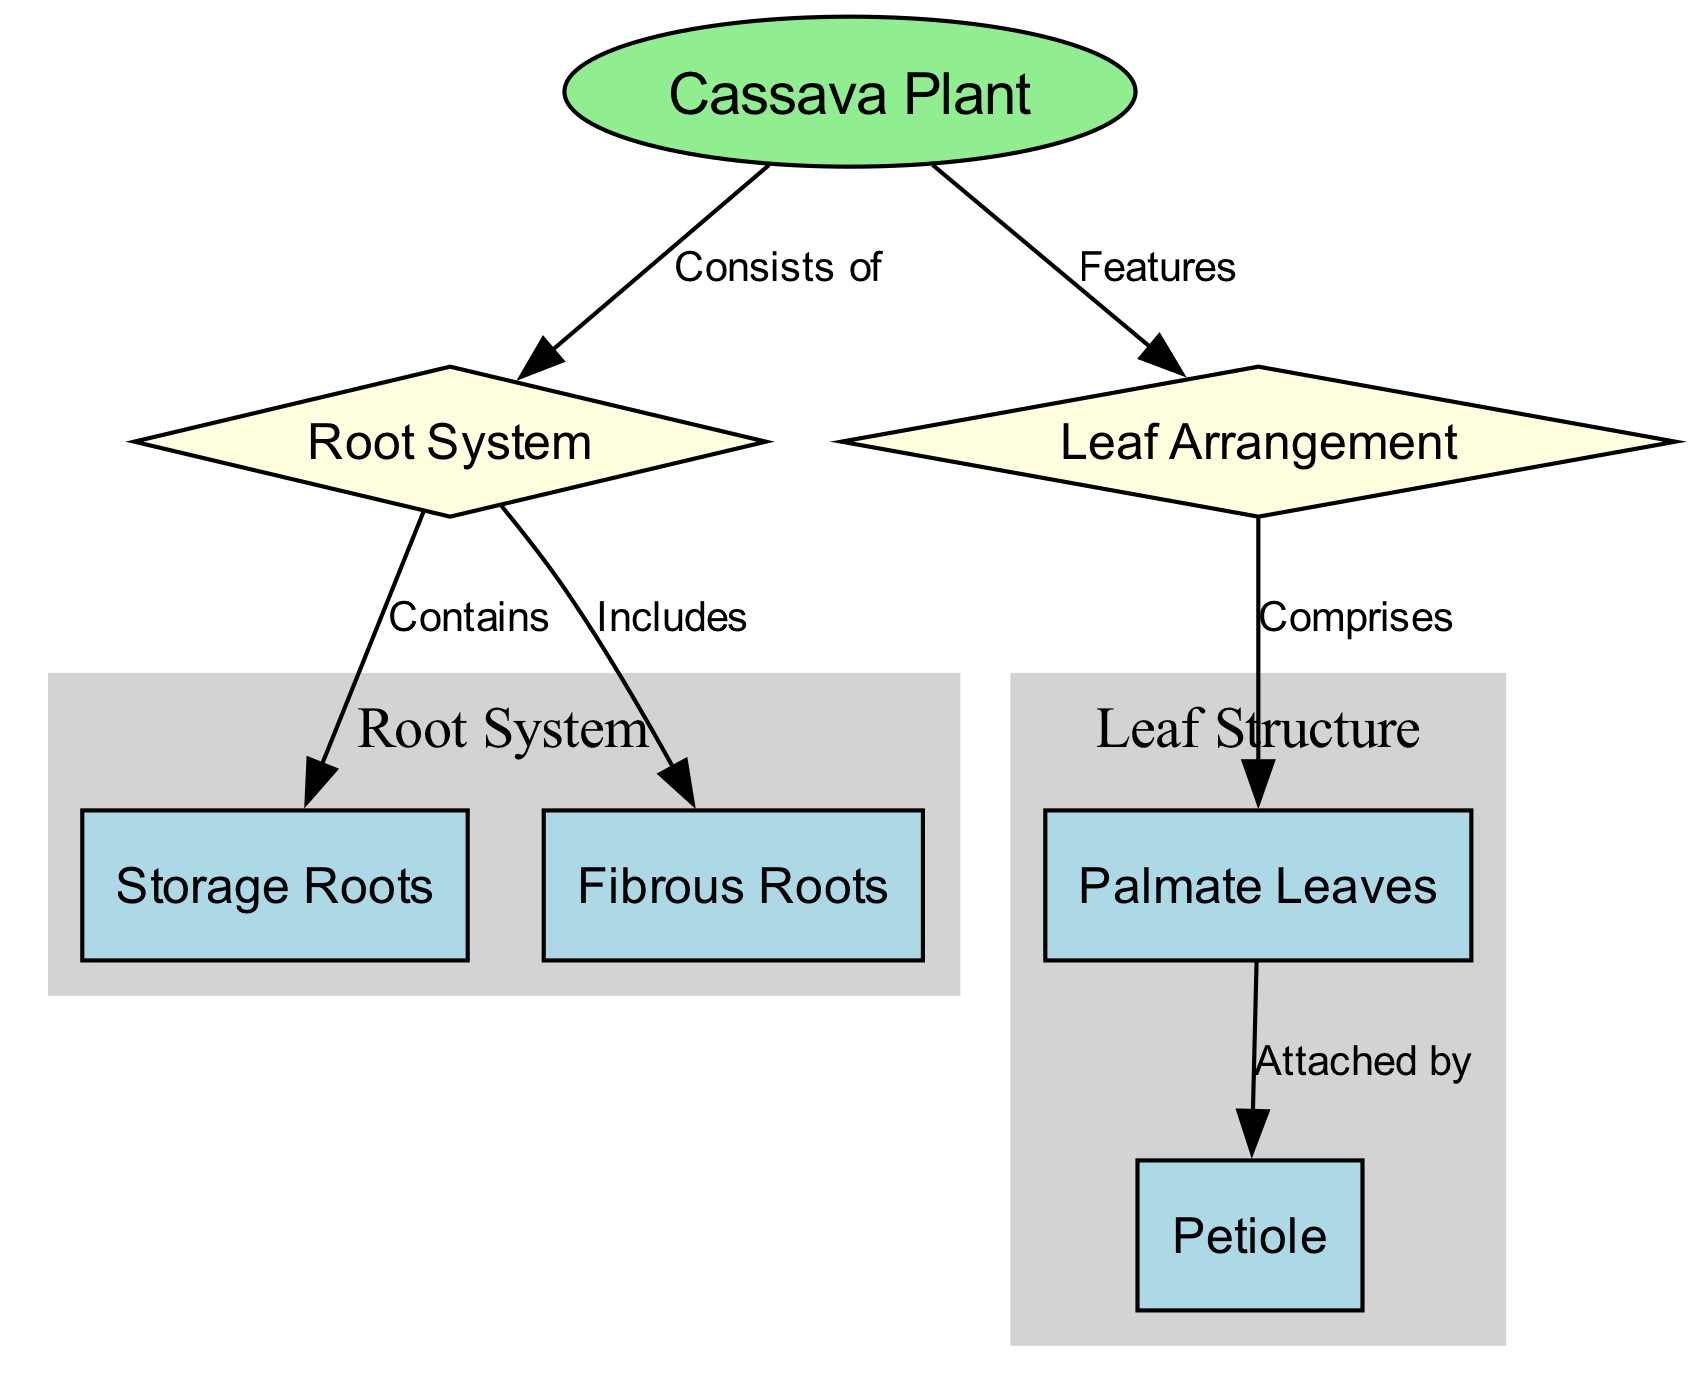What are the two main components of the cassava plant's structure represented in the diagram? The diagram highlights two main components: the root system and the leaf arrangement. These are the primary divisions of the cassava plant as indicated by the edges leading from the cassava plant node to these two nodes.
Answer: Root system and leaf arrangement How many storage roots are connected to the root system in the diagram? The diagram specifies that storage roots are a component of the root system, indicating a singular connection without indicating multiple distinct storage roots. Thus, we consider this as one primary category.
Answer: 1 What type of leaves does the leaf arrangement comprise? The leaf arrangement node indicates that it comprises palmate leaves, as directly connected by the edge labeled "Comprises." This is a direct relationship stated in the diagram.
Answer: Palmate leaves What connects the palmate leaves to the petiole? The diagram shows the connection between palmate leaves and the petiole, represented by the directed edge labeled “Attached by.” This indicates a specific linking relationship.
Answer: Attached by Which component includes fibrous roots? The root system node indicates that it includes fibrous roots specifically as part of its structure through the edge labeled “Includes.” This conveys the hierarchical relationship within the root system.
Answer: Fibrous roots What shape is used to represent the cassava plant in the diagram? The diagram uses an ellipse shape specifically for the cassava plant node, which is an emphasized graphical choice to denote its importance relative to other nodes.
Answer: Ellipse How is the structure of the root system visually represented in this diagram? The root system is illustrated through a diamond shape, distinguishing it as a higher-level structural category connected to both storage and fibrous roots. The subgraph further organizes these components visually.
Answer: Diamond shape What color is the root system node? The root system node is filled with light yellow color according to the attributes defined in the diagram. The visual color coding helps categorize the different components of the cassava plant effectively.
Answer: Light yellow 